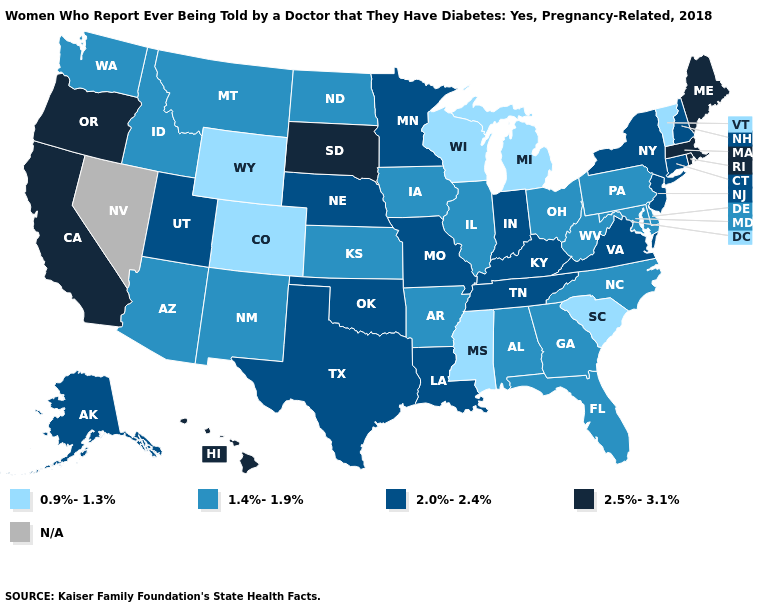Among the states that border Ohio , does Michigan have the lowest value?
Keep it brief. Yes. Name the states that have a value in the range 1.4%-1.9%?
Answer briefly. Alabama, Arizona, Arkansas, Delaware, Florida, Georgia, Idaho, Illinois, Iowa, Kansas, Maryland, Montana, New Mexico, North Carolina, North Dakota, Ohio, Pennsylvania, Washington, West Virginia. Name the states that have a value in the range N/A?
Be succinct. Nevada. What is the value of Montana?
Quick response, please. 1.4%-1.9%. Does Tennessee have the highest value in the South?
Keep it brief. Yes. Name the states that have a value in the range 0.9%-1.3%?
Be succinct. Colorado, Michigan, Mississippi, South Carolina, Vermont, Wisconsin, Wyoming. Name the states that have a value in the range 1.4%-1.9%?
Concise answer only. Alabama, Arizona, Arkansas, Delaware, Florida, Georgia, Idaho, Illinois, Iowa, Kansas, Maryland, Montana, New Mexico, North Carolina, North Dakota, Ohio, Pennsylvania, Washington, West Virginia. Among the states that border Mississippi , which have the highest value?
Keep it brief. Louisiana, Tennessee. What is the highest value in the South ?
Quick response, please. 2.0%-2.4%. Name the states that have a value in the range 0.9%-1.3%?
Be succinct. Colorado, Michigan, Mississippi, South Carolina, Vermont, Wisconsin, Wyoming. What is the value of Ohio?
Answer briefly. 1.4%-1.9%. What is the lowest value in the South?
Write a very short answer. 0.9%-1.3%. What is the value of Kansas?
Be succinct. 1.4%-1.9%. 